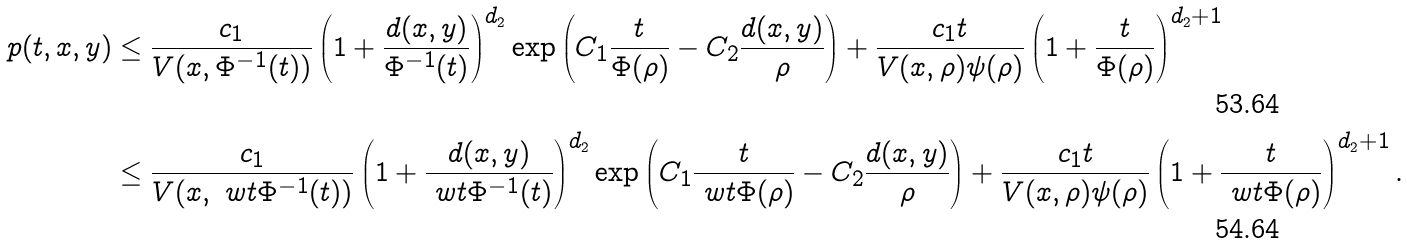Convert formula to latex. <formula><loc_0><loc_0><loc_500><loc_500>p ( t , x , y ) & \leq \frac { c _ { 1 } } { V ( x , \Phi ^ { - 1 } ( t ) ) } \left ( 1 + \frac { d ( x , y ) } { \Phi ^ { - 1 } ( t ) } \right ) ^ { d _ { 2 } } \exp \left ( C _ { 1 } \frac { t } { \Phi ( \rho ) } - C _ { 2 } \frac { d ( x , y ) } { \rho } \right ) + \frac { c _ { 1 } t } { V ( x , \rho ) \psi ( \rho ) } \left ( 1 + \frac { t } { \Phi ( \rho ) } \right ) ^ { d _ { 2 } + 1 } \\ & \leq \frac { c _ { 1 } } { V ( x , \ w t \Phi ^ { - 1 } ( t ) ) } \left ( 1 + \frac { d ( x , y ) } { \ w t \Phi ^ { - 1 } ( t ) } \right ) ^ { d _ { 2 } } \exp \left ( C _ { 1 } \frac { t } { \ w t \Phi ( \rho ) } - C _ { 2 } \frac { d ( x , y ) } { \rho } \right ) + \frac { c _ { 1 } t } { V ( x , \rho ) \psi ( \rho ) } \left ( 1 + \frac { t } { \ w t \Phi ( \rho ) } \right ) ^ { d _ { 2 } + 1 } .</formula> 